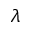Convert formula to latex. <formula><loc_0><loc_0><loc_500><loc_500>\lambda</formula> 